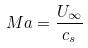<formula> <loc_0><loc_0><loc_500><loc_500>M a = \frac { U _ { \infty } } { c _ { s } }</formula> 